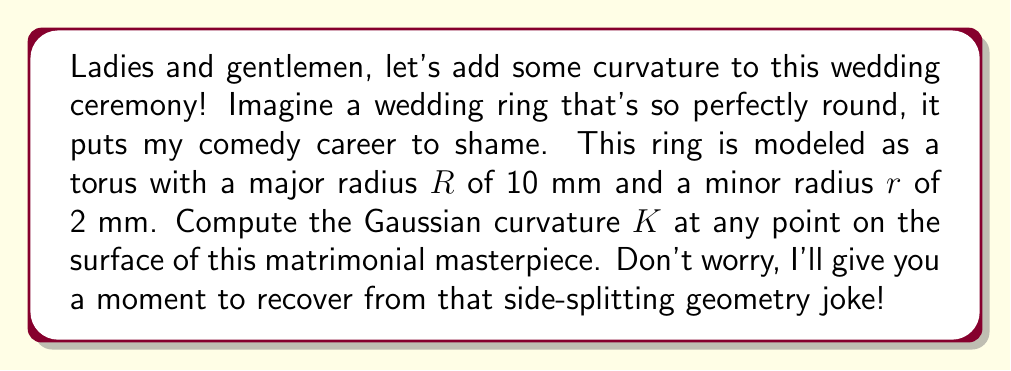What is the answer to this math problem? Alright, let's break this down step by step, just like I break down my jokes during a set:

1) First, we need to recall the formula for the Gaussian curvature $K$ of a torus:

   $$K = \frac{\cos \theta}{r(R + r\cos \theta)}$$

   where $\theta$ is the angle around the minor circle (0 to 2π), $r$ is the minor radius, and $R$ is the major radius.

2) Now, we're asked for the curvature at any point on the surface. The beauty of a torus is that its curvature varies depending on where you are on the surface. It's like marriage - some days are more curved than others!

3) To find the range of curvature values, we need to consider the extreme cases:

   a) When $\cos \theta = 1$ (outer equator), we get the minimum curvature:
      $$K_{min} = \frac{1}{r(R + r)} = \frac{1}{2(10 + 2)} = \frac{1}{24} \approx 0.0417 \text{ mm}^{-2}$$

   b) When $\cos \theta = -1$ (inner equator), we get the maximum curvature:
      $$K_{max} = \frac{-1}{r(R - r)} = \frac{-1}{2(10 - 2)} = -\frac{1}{16} = -0.0625 \text{ mm}^{-2}$$

4) For all other points on the surface, the curvature will fall between these two values.

5) Note that the curvature is positive on the outer part of the torus and negative on the inner part. The line where the curvature changes from positive to negative (where $\cos \theta = 0$) is called the locus of parabolic points.

[asy]
import graph3;
size(200);
currentprojection=perspective(6,3,2);
real R=10, r=2;
triple f(pair t) {return ((R+r*cos(t.y))*cos(t.x),(R+r*cos(t.y))*sin(t.x),r*sin(t.y));}
surface s=surface(f,(0,0),(2pi,2pi),8,8,Spline);
draw(s,paleblue);
draw(shift(0,0,-r)*scale3(R)*unitcircle3,blue);
draw(shift(R,0,0)*scale3(r)*unitcircle3,red);
label("R",((R+r)/2,0,0),N);
label("r",(R,0,r/2),E);
[/asy]

And there you have it! A ring of curvature that's as varied as the emotions at a wedding.
Answer: The Gaussian curvature $K$ at any point on the surface of the wedding ring torus varies between $K_{min} = \frac{1}{24} \approx 0.0417 \text{ mm}^{-2}$ and $K_{max} = -\frac{1}{16} = -0.0625 \text{ mm}^{-2}$, depending on the position on the torus surface. 